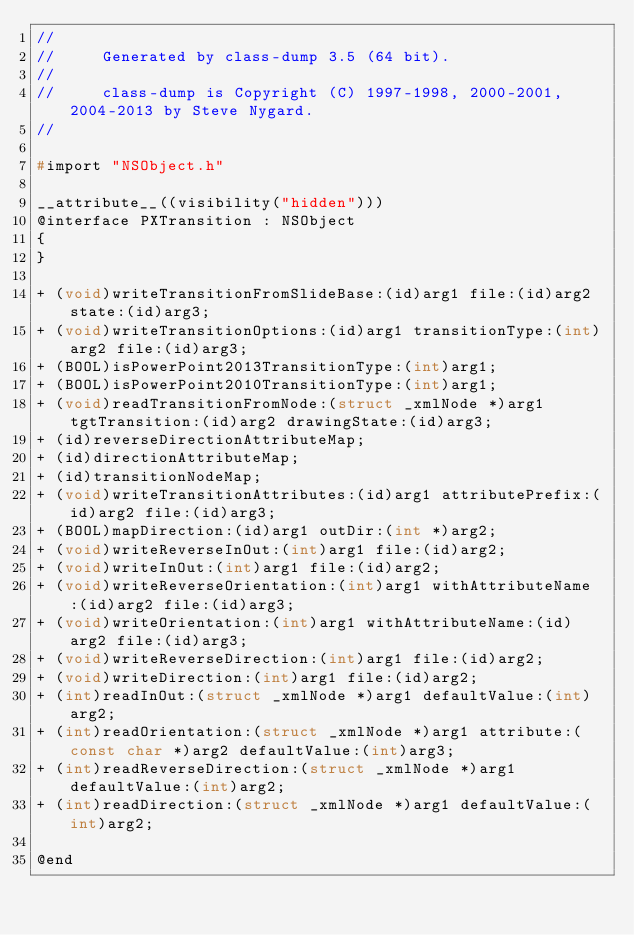<code> <loc_0><loc_0><loc_500><loc_500><_C_>//
//     Generated by class-dump 3.5 (64 bit).
//
//     class-dump is Copyright (C) 1997-1998, 2000-2001, 2004-2013 by Steve Nygard.
//

#import "NSObject.h"

__attribute__((visibility("hidden")))
@interface PXTransition : NSObject
{
}

+ (void)writeTransitionFromSlideBase:(id)arg1 file:(id)arg2 state:(id)arg3;
+ (void)writeTransitionOptions:(id)arg1 transitionType:(int)arg2 file:(id)arg3;
+ (BOOL)isPowerPoint2013TransitionType:(int)arg1;
+ (BOOL)isPowerPoint2010TransitionType:(int)arg1;
+ (void)readTransitionFromNode:(struct _xmlNode *)arg1 tgtTransition:(id)arg2 drawingState:(id)arg3;
+ (id)reverseDirectionAttributeMap;
+ (id)directionAttributeMap;
+ (id)transitionNodeMap;
+ (void)writeTransitionAttributes:(id)arg1 attributePrefix:(id)arg2 file:(id)arg3;
+ (BOOL)mapDirection:(id)arg1 outDir:(int *)arg2;
+ (void)writeReverseInOut:(int)arg1 file:(id)arg2;
+ (void)writeInOut:(int)arg1 file:(id)arg2;
+ (void)writeReverseOrientation:(int)arg1 withAttributeName:(id)arg2 file:(id)arg3;
+ (void)writeOrientation:(int)arg1 withAttributeName:(id)arg2 file:(id)arg3;
+ (void)writeReverseDirection:(int)arg1 file:(id)arg2;
+ (void)writeDirection:(int)arg1 file:(id)arg2;
+ (int)readInOut:(struct _xmlNode *)arg1 defaultValue:(int)arg2;
+ (int)readOrientation:(struct _xmlNode *)arg1 attribute:(const char *)arg2 defaultValue:(int)arg3;
+ (int)readReverseDirection:(struct _xmlNode *)arg1 defaultValue:(int)arg2;
+ (int)readDirection:(struct _xmlNode *)arg1 defaultValue:(int)arg2;

@end

</code> 